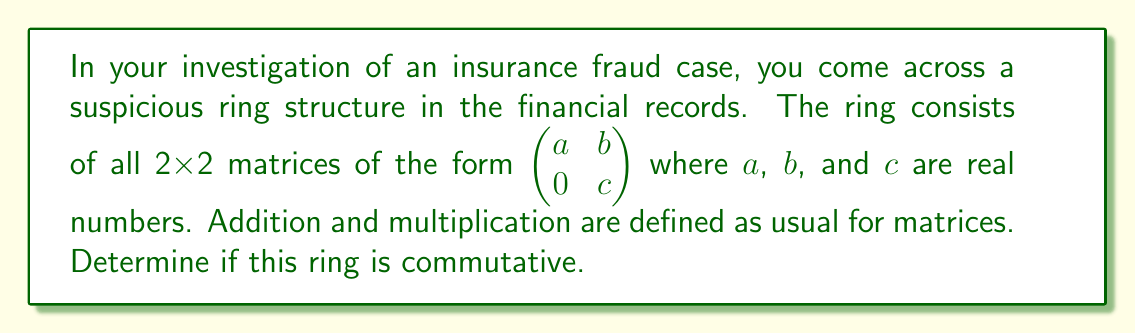Could you help me with this problem? To determine if the given ring is commutative, we need to check if multiplication is commutative for all elements in the ring. Let's approach this step-by-step:

1) Consider two general elements of the ring:

   $A = \begin{pmatrix} a_1 & b_1 \\ 0 & c_1 \end{pmatrix}$ and $B = \begin{pmatrix} a_2 & b_2 \\ 0 & c_2 \end{pmatrix}$

2) Calculate $AB$:

   $AB = \begin{pmatrix} a_1 & b_1 \\ 0 & c_1 \end{pmatrix} \begin{pmatrix} a_2 & b_2 \\ 0 & c_2 \end{pmatrix} = \begin{pmatrix} a_1a_2 & a_1b_2 + b_1c_2 \\ 0 & c_1c_2 \end{pmatrix}$

3) Calculate $BA$:

   $BA = \begin{pmatrix} a_2 & b_2 \\ 0 & c_2 \end{pmatrix} \begin{pmatrix} a_1 & b_1 \\ 0 & c_1 \end{pmatrix} = \begin{pmatrix} a_2a_1 & a_2b_1 + b_2c_1 \\ 0 & c_2c_1 \end{pmatrix}$

4) For the ring to be commutative, we must have $AB = BA$ for all choices of $a_1$, $b_1$, $c_1$, $a_2$, $b_2$, and $c_2$.

5) Comparing $AB$ and $BA$:
   - The (1,1) elements are equal: $a_1a_2 = a_2a_1$ (multiplication of real numbers is commutative)
   - The (2,2) elements are equal: $c_1c_2 = c_2c_1$ (multiplication of real numbers is commutative)
   - However, the (1,2) elements are not always equal: $a_1b_2 + b_1c_2 \neq a_2b_1 + b_2c_1$ in general

6) We can find a specific counterexample:
   Let $A = \begin{pmatrix} 1 & 1 \\ 0 & 2 \end{pmatrix}$ and $B = \begin{pmatrix} 2 & 1 \\ 0 & 1 \end{pmatrix}$

   Then $AB = \begin{pmatrix} 2 & 3 \\ 0 & 2 \end{pmatrix}$ but $BA = \begin{pmatrix} 2 & 2 \\ 0 & 2 \end{pmatrix}$

Therefore, the ring is not commutative.
Answer: The given ring is not commutative. 